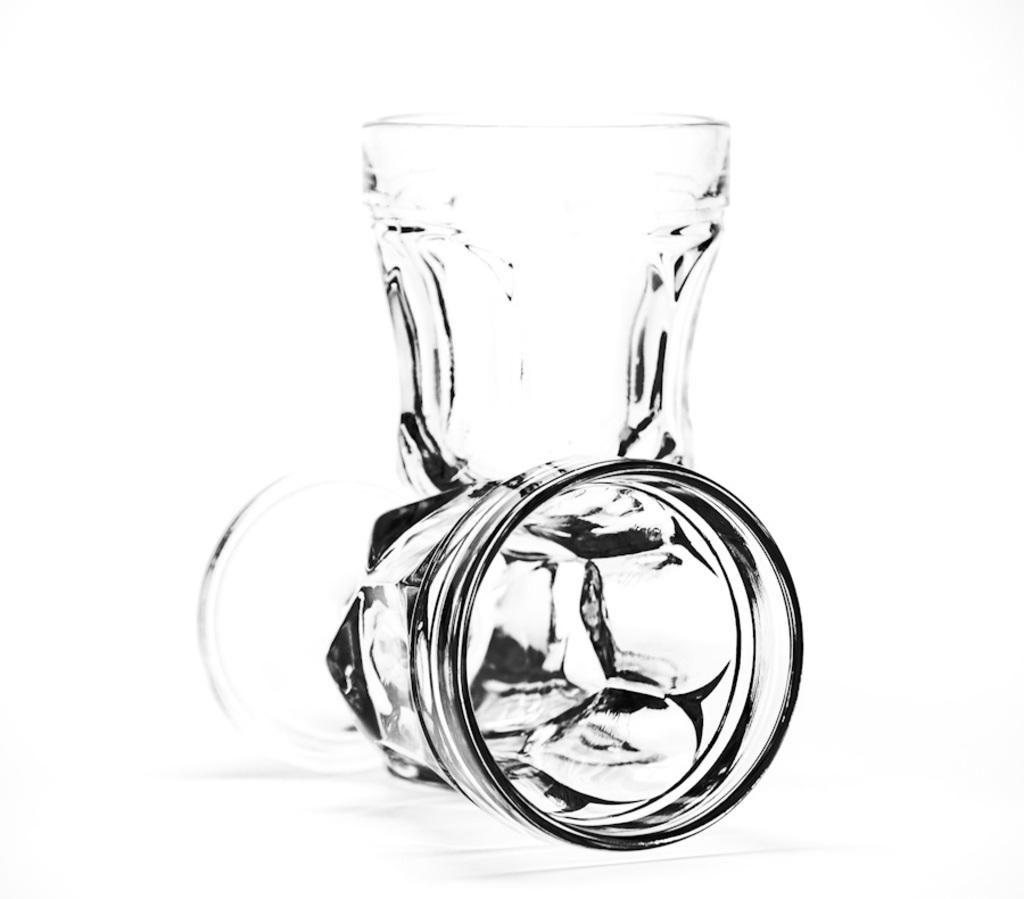What objects can be seen in the image? There are glasses in the image. What color is the background of the image? The background of the image is white. Can you see the mom's approval in the image? There is no reference to a mom or approval in the image; it only features glasses against a white background. 